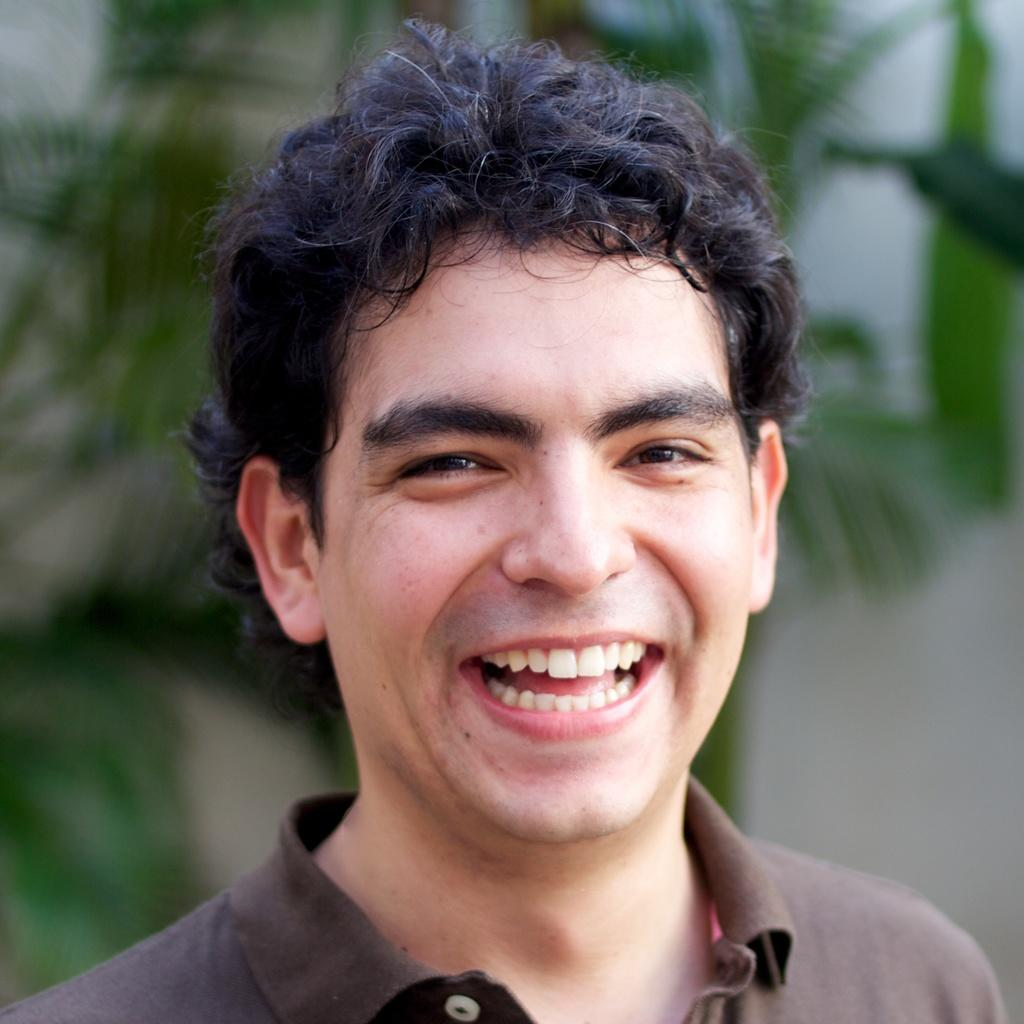What is the main subject of the image? There is a person in the image. What is the person's facial expression? The person is smiling. What can be seen in the background of the image? There are trees visible behind the person. What hobbies does the person enjoy during a rainstorm in the image? There is no indication of a rainstorm or any hobbies in the image. How many houses are visible in the image? There are no houses visible in the image; only a person and trees are present. 